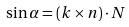<formula> <loc_0><loc_0><loc_500><loc_500>\sin \alpha = ( k \times n ) \cdot N</formula> 